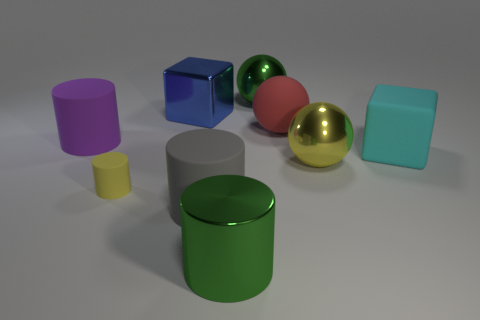What material is the large ball that is the same color as the small matte cylinder?
Ensure brevity in your answer.  Metal. Are there fewer big blue blocks than shiny objects?
Offer a terse response. Yes. What shape is the yellow shiny object that is the same size as the gray thing?
Keep it short and to the point. Sphere. How many other things are the same color as the rubber ball?
Keep it short and to the point. 0. What number of big rubber cylinders are there?
Your answer should be very brief. 2. What number of large balls are both behind the big metal cube and in front of the big rubber cube?
Offer a terse response. 0. What material is the large yellow thing?
Provide a short and direct response. Metal. Are there any gray cylinders?
Your answer should be very brief. Yes. The cube right of the gray matte thing is what color?
Offer a terse response. Cyan. How many green cylinders are left of the big block that is to the left of the green metal thing in front of the blue block?
Make the answer very short. 0. 